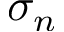Convert formula to latex. <formula><loc_0><loc_0><loc_500><loc_500>\sigma _ { n }</formula> 